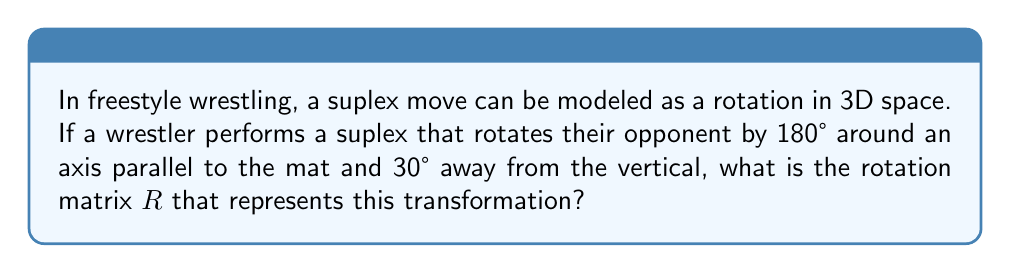Provide a solution to this math problem. Let's approach this step-by-step:

1) First, we need to set up our coordinate system. Let's assume:
   - The x-axis is along the length of the mat
   - The y-axis is across the width of the mat
   - The z-axis is vertical, perpendicular to the mat

2) The axis of rotation is 30° from the vertical, which means it's 60° from the horizontal plane. Let's call this angle $\theta = 60°$.

3) The rotation axis can be described by the unit vector:
   $$\vec{u} = (\sin\theta, 0, \cos\theta) = (\frac{\sqrt{3}}{2}, 0, \frac{1}{2})$$

4) For a rotation of $\phi = 180°$ around an arbitrary axis $\vec{u} = (u_x, u_y, u_z)$, the rotation matrix is given by:

   $$R = \cos\phi I + (1-\cos\phi)\vec{u}\vec{u}^T + \sin\phi[\vec{u}]_\times$$

   where $I$ is the 3x3 identity matrix and $[\vec{u}]_\times$ is the cross-product matrix of $\vec{u}$.

5) Substituting our values:
   $$\cos\phi = -1, \sin\phi = 0, u_x = \frac{\sqrt{3}}{2}, u_y = 0, u_z = \frac{1}{2}$$

6) The rotation matrix becomes:

   $$R = -I + 2\vec{u}\vec{u}^T$$

7) Expanding this:

   $$R = \begin{bmatrix}
   -1 & 0 & 0 \\
   0 & -1 & 0 \\
   0 & 0 & -1
   \end{bmatrix} + 2\begin{bmatrix}
   \frac{3}{4} & 0 & \frac{\sqrt{3}}{4} \\
   0 & 0 & 0 \\
   \frac{\sqrt{3}}{4} & 0 & \frac{1}{4}
   \end{bmatrix}$$

8) Simplifying:

   $$R = \begin{bmatrix}
   \frac{1}{2} & 0 & \frac{\sqrt{3}}{2} \\
   0 & -1 & 0 \\
   \frac{\sqrt{3}}{2} & 0 & -\frac{1}{2}
   \end{bmatrix}$$
Answer: $$R = \begin{bmatrix}
\frac{1}{2} & 0 & \frac{\sqrt{3}}{2} \\
0 & -1 & 0 \\
\frac{\sqrt{3}}{2} & 0 & -\frac{1}{2}
\end{bmatrix}$$ 